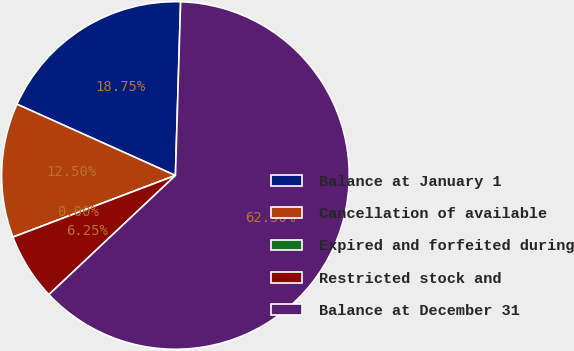Convert chart to OTSL. <chart><loc_0><loc_0><loc_500><loc_500><pie_chart><fcel>Balance at January 1<fcel>Cancellation of available<fcel>Expired and forfeited during<fcel>Restricted stock and<fcel>Balance at December 31<nl><fcel>18.75%<fcel>12.5%<fcel>0.0%<fcel>6.25%<fcel>62.5%<nl></chart> 